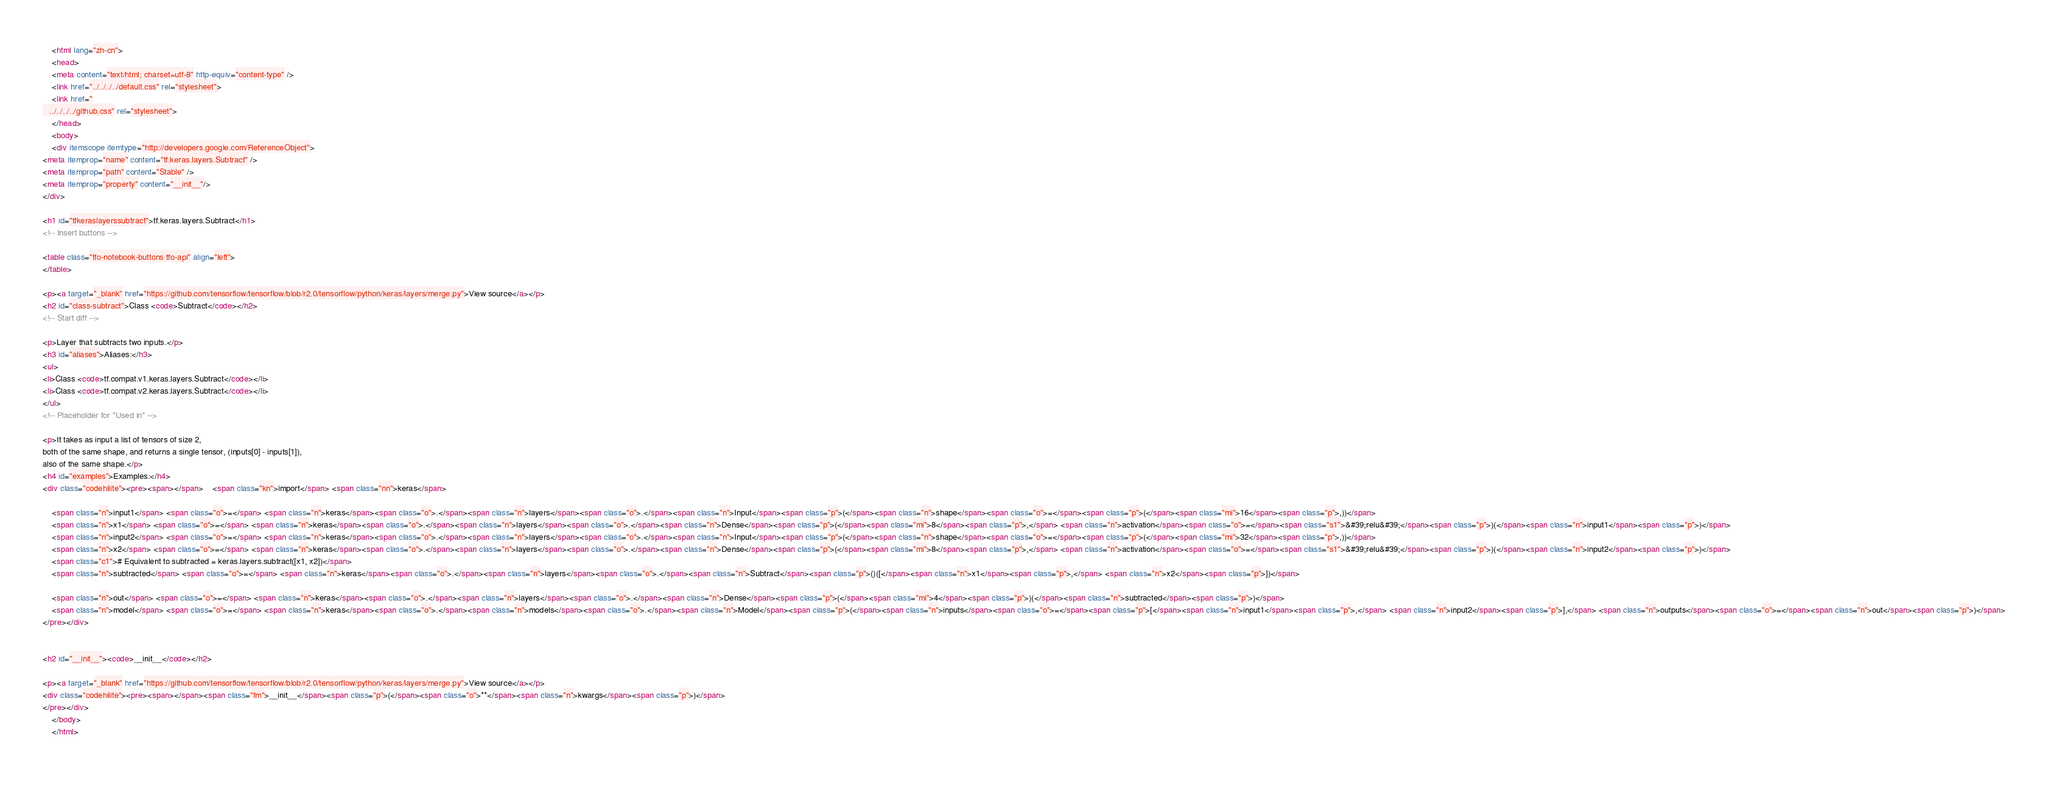<code> <loc_0><loc_0><loc_500><loc_500><_HTML_>
    <html lang="zh-cn">
    <head>
    <meta content="text/html; charset=utf-8" http-equiv="content-type" />
    <link href="../../../../default.css" rel="stylesheet">
    <link href="
   ../../../../github.css" rel="stylesheet">
    </head>
    <body>
    <div itemscope itemtype="http://developers.google.com/ReferenceObject">
<meta itemprop="name" content="tf.keras.layers.Subtract" />
<meta itemprop="path" content="Stable" />
<meta itemprop="property" content="__init__"/>
</div>

<h1 id="tfkeraslayerssubtract">tf.keras.layers.Subtract</h1>
<!-- Insert buttons -->

<table class="tfo-notebook-buttons tfo-api" align="left">
</table>

<p><a target="_blank" href="https://github.com/tensorflow/tensorflow/blob/r2.0/tensorflow/python/keras/layers/merge.py">View source</a></p>
<h2 id="class-subtract">Class <code>Subtract</code></h2>
<!-- Start diff -->

<p>Layer that subtracts two inputs.</p>
<h3 id="aliases">Aliases:</h3>
<ul>
<li>Class <code>tf.compat.v1.keras.layers.Subtract</code></li>
<li>Class <code>tf.compat.v2.keras.layers.Subtract</code></li>
</ul>
<!-- Placeholder for "Used in" -->

<p>It takes as input a list of tensors of size 2,
both of the same shape, and returns a single tensor, (inputs[0] - inputs[1]),
also of the same shape.</p>
<h4 id="examples">Examples:</h4>
<div class="codehilite"><pre><span></span>    <span class="kn">import</span> <span class="nn">keras</span>

    <span class="n">input1</span> <span class="o">=</span> <span class="n">keras</span><span class="o">.</span><span class="n">layers</span><span class="o">.</span><span class="n">Input</span><span class="p">(</span><span class="n">shape</span><span class="o">=</span><span class="p">(</span><span class="mi">16</span><span class="p">,))</span>
    <span class="n">x1</span> <span class="o">=</span> <span class="n">keras</span><span class="o">.</span><span class="n">layers</span><span class="o">.</span><span class="n">Dense</span><span class="p">(</span><span class="mi">8</span><span class="p">,</span> <span class="n">activation</span><span class="o">=</span><span class="s1">&#39;relu&#39;</span><span class="p">)(</span><span class="n">input1</span><span class="p">)</span>
    <span class="n">input2</span> <span class="o">=</span> <span class="n">keras</span><span class="o">.</span><span class="n">layers</span><span class="o">.</span><span class="n">Input</span><span class="p">(</span><span class="n">shape</span><span class="o">=</span><span class="p">(</span><span class="mi">32</span><span class="p">,))</span>
    <span class="n">x2</span> <span class="o">=</span> <span class="n">keras</span><span class="o">.</span><span class="n">layers</span><span class="o">.</span><span class="n">Dense</span><span class="p">(</span><span class="mi">8</span><span class="p">,</span> <span class="n">activation</span><span class="o">=</span><span class="s1">&#39;relu&#39;</span><span class="p">)(</span><span class="n">input2</span><span class="p">)</span>
    <span class="c1"># Equivalent to subtracted = keras.layers.subtract([x1, x2])</span>
    <span class="n">subtracted</span> <span class="o">=</span> <span class="n">keras</span><span class="o">.</span><span class="n">layers</span><span class="o">.</span><span class="n">Subtract</span><span class="p">()([</span><span class="n">x1</span><span class="p">,</span> <span class="n">x2</span><span class="p">])</span>

    <span class="n">out</span> <span class="o">=</span> <span class="n">keras</span><span class="o">.</span><span class="n">layers</span><span class="o">.</span><span class="n">Dense</span><span class="p">(</span><span class="mi">4</span><span class="p">)(</span><span class="n">subtracted</span><span class="p">)</span>
    <span class="n">model</span> <span class="o">=</span> <span class="n">keras</span><span class="o">.</span><span class="n">models</span><span class="o">.</span><span class="n">Model</span><span class="p">(</span><span class="n">inputs</span><span class="o">=</span><span class="p">[</span><span class="n">input1</span><span class="p">,</span> <span class="n">input2</span><span class="p">],</span> <span class="n">outputs</span><span class="o">=</span><span class="n">out</span><span class="p">)</span>
</pre></div>


<h2 id="__init__"><code>__init__</code></h2>

<p><a target="_blank" href="https://github.com/tensorflow/tensorflow/blob/r2.0/tensorflow/python/keras/layers/merge.py">View source</a></p>
<div class="codehilite"><pre><span></span><span class="fm">__init__</span><span class="p">(</span><span class="o">**</span><span class="n">kwargs</span><span class="p">)</span>
</pre></div>
    </body>
    </html>
   </code> 